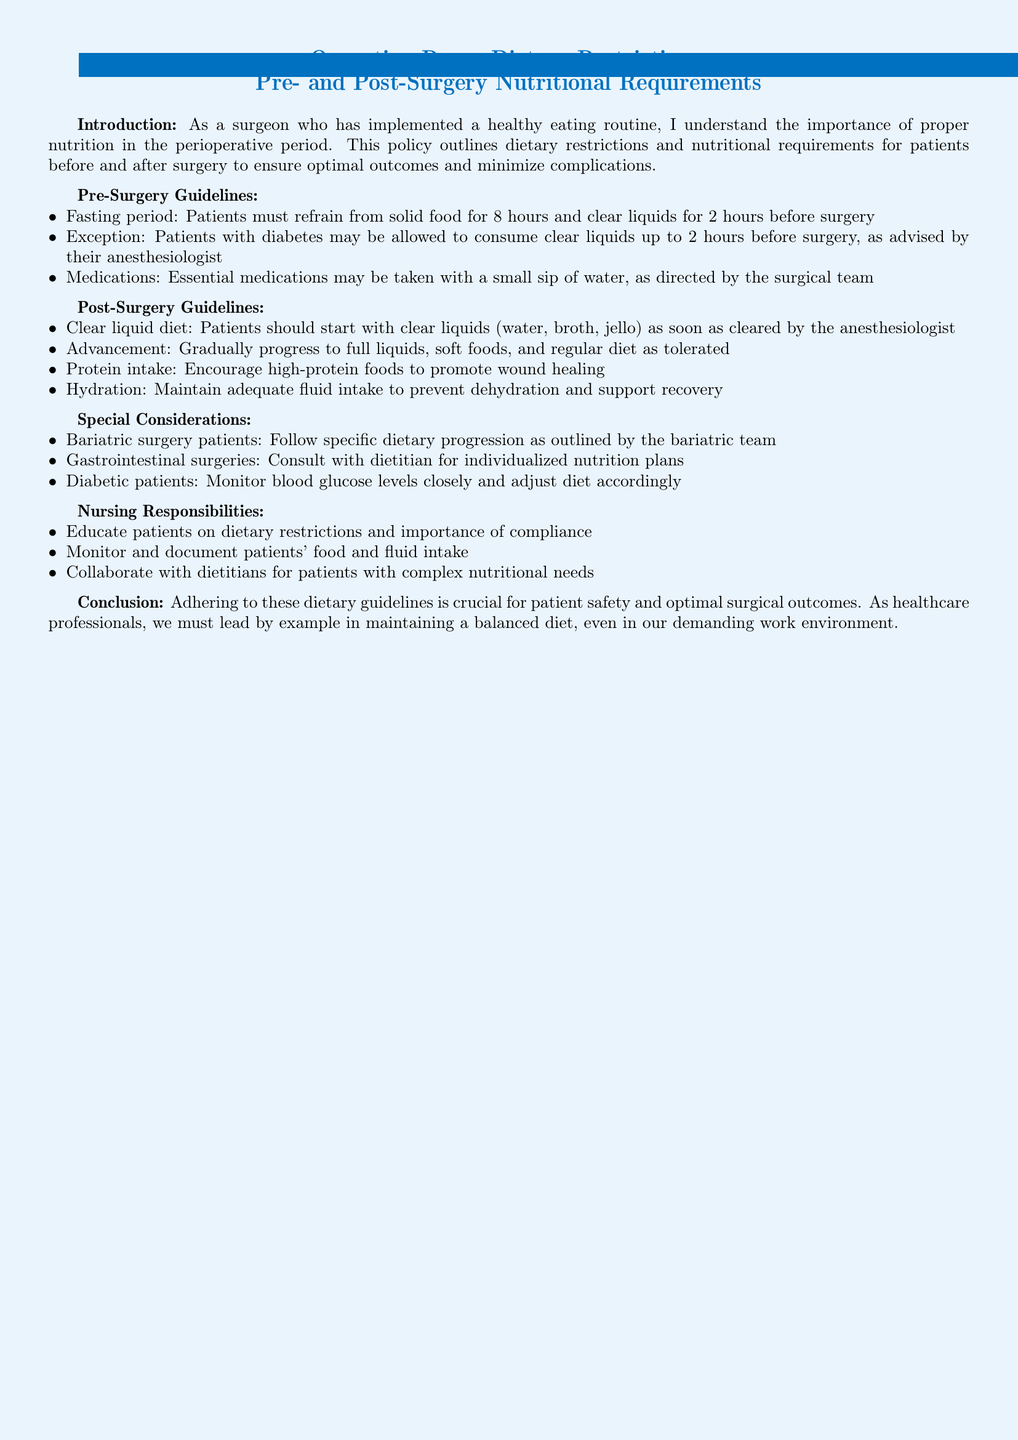What is the fasting period required before surgery? The fasting period is specified as 8 hours for solid food and 2 hours for clear liquids before surgery.
Answer: 8 hours for solid food, 2 hours for clear liquids What type of diet should patients start with post-surgery? The document indicates that patients should begin with a clear liquid diet as soon as cleared by the anesthesiologist.
Answer: Clear liquid diet Who may consume clear liquids up to 2 hours before surgery? The document states that patients with diabetes may be allowed to consume clear liquids up to 2 hours before surgery, as advised by their anesthesiologist.
Answer: Patients with diabetes What is encouraged to promote wound healing post-surgery? The policy recommends encouraging high-protein foods to promote wound healing after surgery.
Answer: High-protein foods Which patients require consultation with a dietitian for individualized nutrition plans? The document specifies that patients who have had gastrointestinal surgeries should consult with a dietitian for individualized nutrition plans.
Answer: Gastrointestinal surgeries patients What should nursing staff educate patients about? According to the guidelines, nursing staff are responsible for educating patients on dietary restrictions and the importance of compliance.
Answer: Dietary restrictions and compliance What is the ultimate goal of adhering to the dietary guidelines stated in the document? The conclusion emphasizes that adhering to these guidelines is crucial for patient safety and optimal surgical outcomes.
Answer: Patient safety and optimal surgical outcomes How should dietary progression be handled for bariatric surgery patients? The document advises that bariatric surgery patients should follow specific dietary progression as outlined by the bariatric team.
Answer: Follow specific dietary progression What should be monitored closely for diabetic patients post-surgery? The document specifies that diabetic patients should have their blood glucose levels closely monitored and adjusted diet accordingly.
Answer: Blood glucose levels 